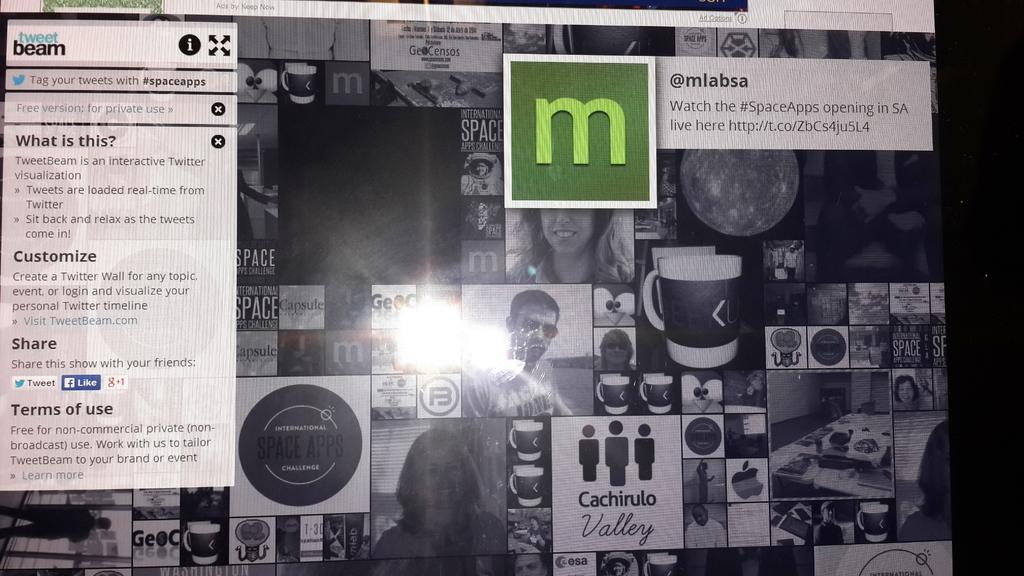What is the main subject of the image? The main subject of the image is a web page. What type of badge can be seen on the plantation in the image? There is no badge or plantation present in the image, as it features a web page. 